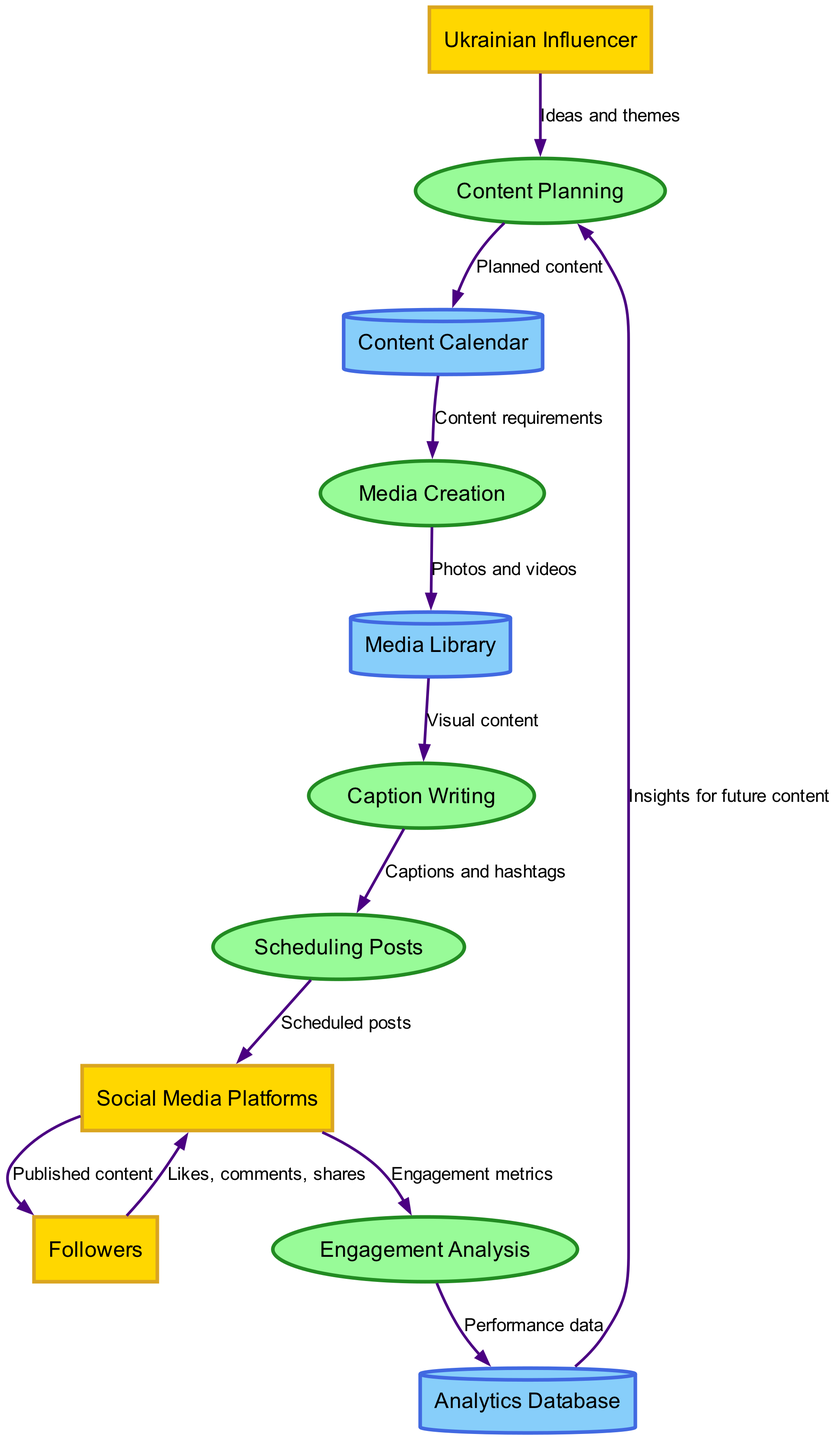What are the external entities in the diagram? The external entities specified in the diagram are "Ukrainian Influencer," "Followers," and "Social Media Platforms." These entities represent the parties that interact with the processes outlined in the diagram.
Answer: Ukrainian Influencer, Followers, Social Media Platforms How many processes are there in the diagram? The diagram includes five processes: "Content Planning," "Media Creation," "Caption Writing," "Scheduling Posts," and "Engagement Analysis." These processes are crucial steps in the social media content creation and scheduling workflow.
Answer: 5 Which process receives "Ideas and themes" as input? The "Content Planning" process receives "Ideas and themes" as input from the "Ukrainian Influencer." This shows that the influencer's ideas are foundational for planning content.
Answer: Content Planning What type of data store holds "Photos and videos"? The "Media Library" is the data store that holds "Photos and videos." This storage facilitates the use of visual content during the content creation process.
Answer: Media Library What is the final output of the scheduling process? The final output of the "Scheduling Posts" process is "Scheduled posts" sent to the "Social Media Platforms." This indicates that after finalizing the posts, they are prepared for publication on social media.
Answer: Scheduled posts Which process provides "Insights for future content"? The process that provides "Insights for future content" is "Engagement Analysis." This process analyzes engagement metrics to offer insights that inform future content strategies.
Answer: Engagement Analysis How does "Engagement Analysis" receive data? "Engagement Analysis" receives "Engagement metrics" from "Social Media Platforms." This flow shows that the engagement data gathered from published content is used for analysis.
Answer: Engagement metrics What information is stored in the Analytics Database? The "Analytics Database" stores "Performance data." This data is critical for understanding how content performs over time, aiding in future content planning.
Answer: Performance data What type of relationship exists between "Followers" and "Social Media Platforms"? The relationship between "Followers" and "Social Media Platforms" consists of "Likes, comments, shares." This indicates the interaction users have with the content published on social media.
Answer: Likes, comments, shares What does the "Media Creation" process rely on from the "Content Calendar"? The "Media Creation" process relies on "Content requirements" provided by the "Content Calendar." This demonstrates that the planning stage specifies what kind of media needs to be created.
Answer: Content requirements 